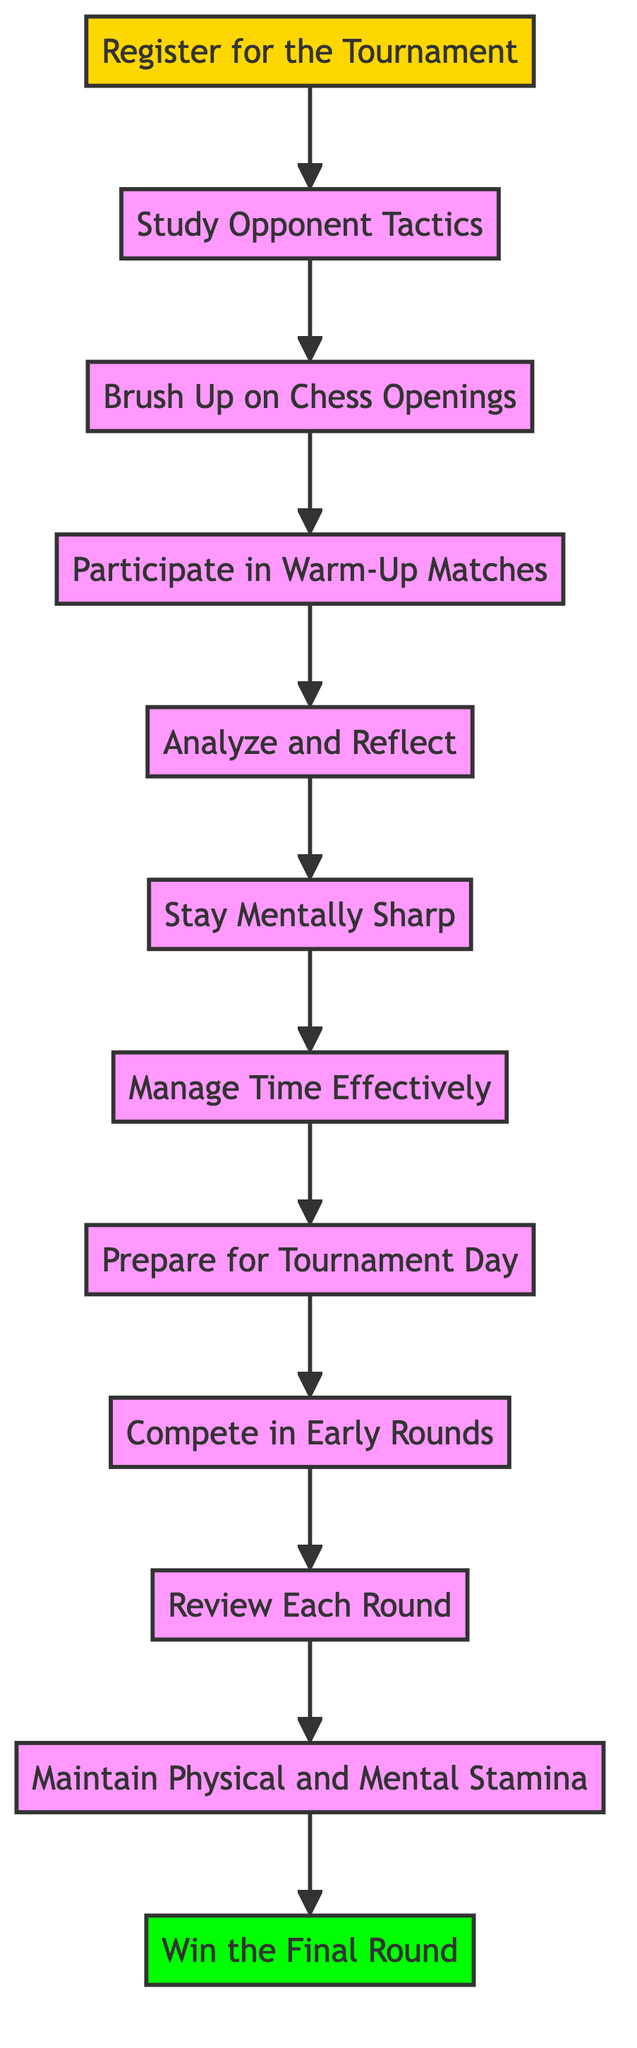What is the first step in preparing for a chess tournament? The diagram lists "Register for the Tournament" as the first node, indicating it is the initial step in the preparation process.
Answer: Register for the Tournament How many total steps are involved in the preparation process? By counting the nodes in the flowchart from the first step to the final round, we find there are twelve distinct steps included in the diagram.
Answer: Twelve What is the final step in the preparation process described in the diagram? The last node in the flowchart points to "Win the Final Round," which is the conclusion of the preparation steps for the tournament.
Answer: Win the Final Round What step comes immediately before "Prepare for Tournament Day"? Tracing the arrows in the diagram shows that "Manage Time Effectively" is directly before the "Prepare for Tournament Day" step.
Answer: Manage Time Effectively Which step encourages the player to analyze past games during the tournament? The "Review Each Round" step specifically calls for analyzing the completed games to adapt future strategies during the competition.
Answer: Review Each Round What is the relationship between "Analyze and Reflect" and "Brush Up on Chess Openings"? In the diagram, "Analyze and Reflect" follows the "Brush Up on Chess Openings," indicating that after revisiting openings, the player should analyze their practice games.
Answer: Sequential relationship Which step involves solving puzzles and cognitive exercises? The diagram states that "Stay Mentally Sharp" involves maintaining mental agility through solving chess puzzles and engaging in cognitive exercises.
Answer: Stay Mentally Sharp What is necessary to compete effectively in the early rounds? The "Compete in Early Rounds" step emphasizes the application of calculated strategies and focus, essential for advancing during these matches.
Answer: Apply calculated strategies What is needed on the tournament day according to the preparation steps? "Prepare for Tournament Day" outlines the need for having all necessary equipment and planning logistics to ensure timely arrival at the venue.
Answer: Necessary equipment and logistics 